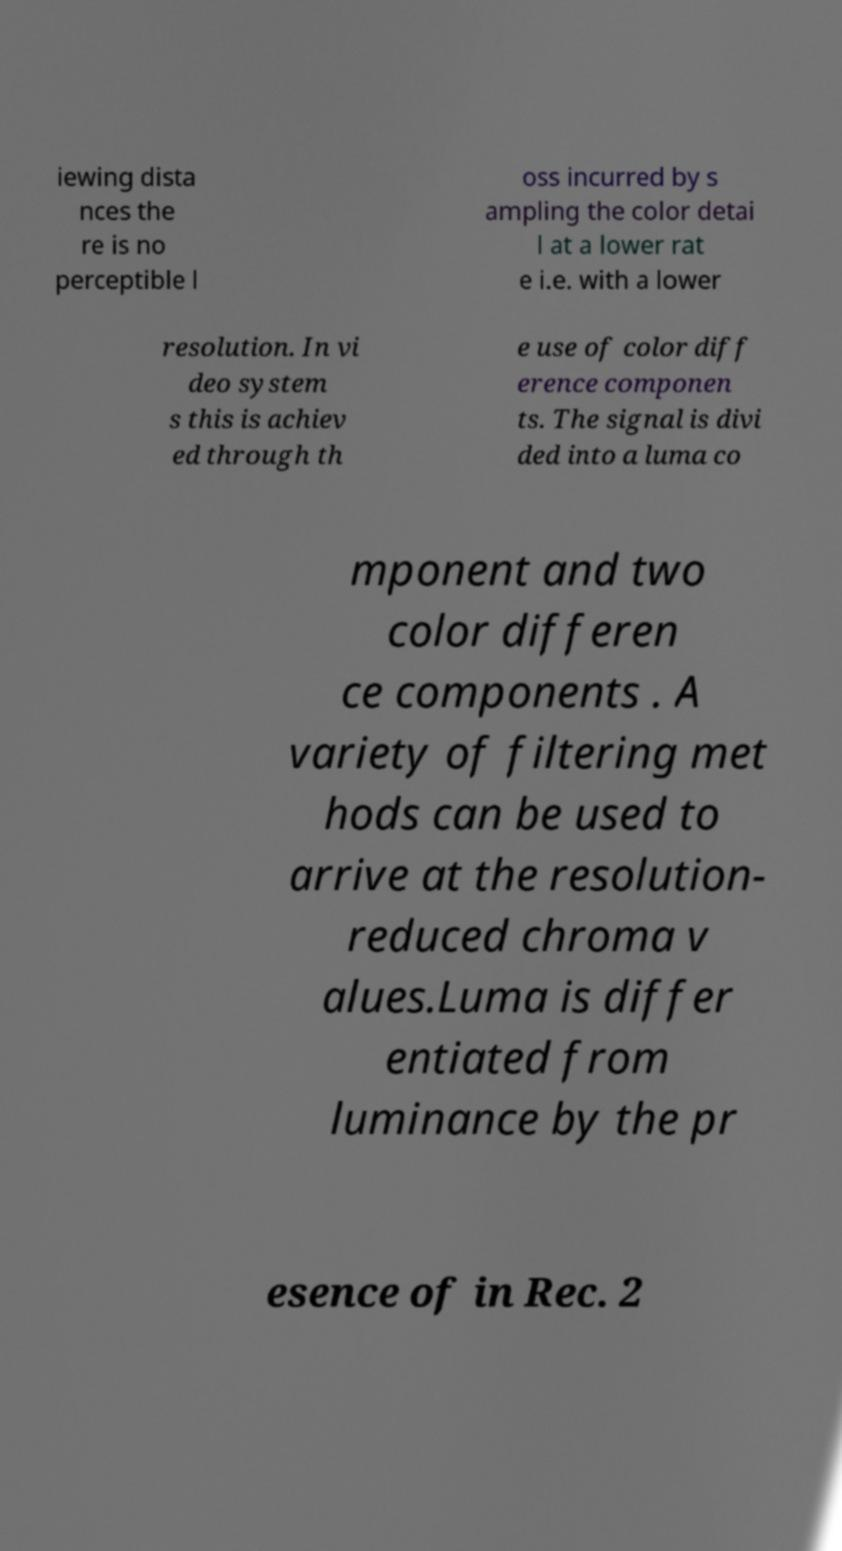Could you extract and type out the text from this image? iewing dista nces the re is no perceptible l oss incurred by s ampling the color detai l at a lower rat e i.e. with a lower resolution. In vi deo system s this is achiev ed through th e use of color diff erence componen ts. The signal is divi ded into a luma co mponent and two color differen ce components . A variety of filtering met hods can be used to arrive at the resolution- reduced chroma v alues.Luma is differ entiated from luminance by the pr esence of in Rec. 2 